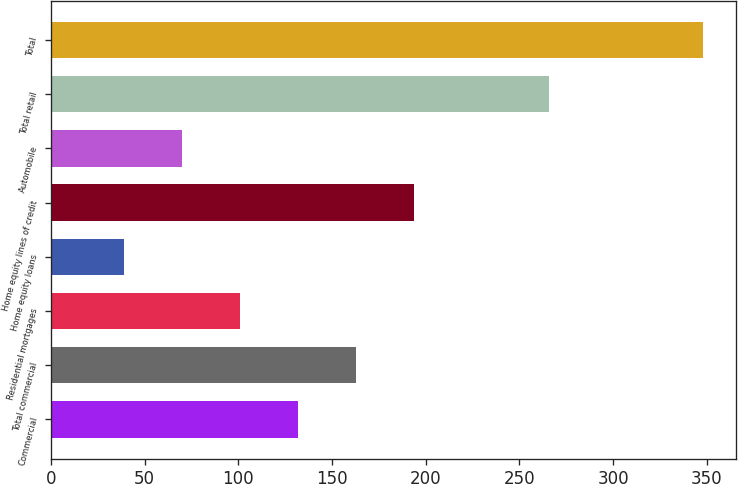<chart> <loc_0><loc_0><loc_500><loc_500><bar_chart><fcel>Commercial<fcel>Total commercial<fcel>Residential mortgages<fcel>Home equity loans<fcel>Home equity lines of credit<fcel>Automobile<fcel>Total retail<fcel>Total<nl><fcel>131.7<fcel>162.6<fcel>100.8<fcel>39<fcel>193.5<fcel>69.9<fcel>266<fcel>348<nl></chart> 